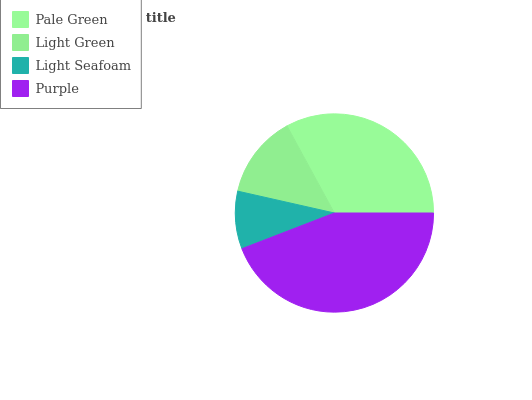Is Light Seafoam the minimum?
Answer yes or no. Yes. Is Purple the maximum?
Answer yes or no. Yes. Is Light Green the minimum?
Answer yes or no. No. Is Light Green the maximum?
Answer yes or no. No. Is Pale Green greater than Light Green?
Answer yes or no. Yes. Is Light Green less than Pale Green?
Answer yes or no. Yes. Is Light Green greater than Pale Green?
Answer yes or no. No. Is Pale Green less than Light Green?
Answer yes or no. No. Is Pale Green the high median?
Answer yes or no. Yes. Is Light Green the low median?
Answer yes or no. Yes. Is Light Green the high median?
Answer yes or no. No. Is Pale Green the low median?
Answer yes or no. No. 